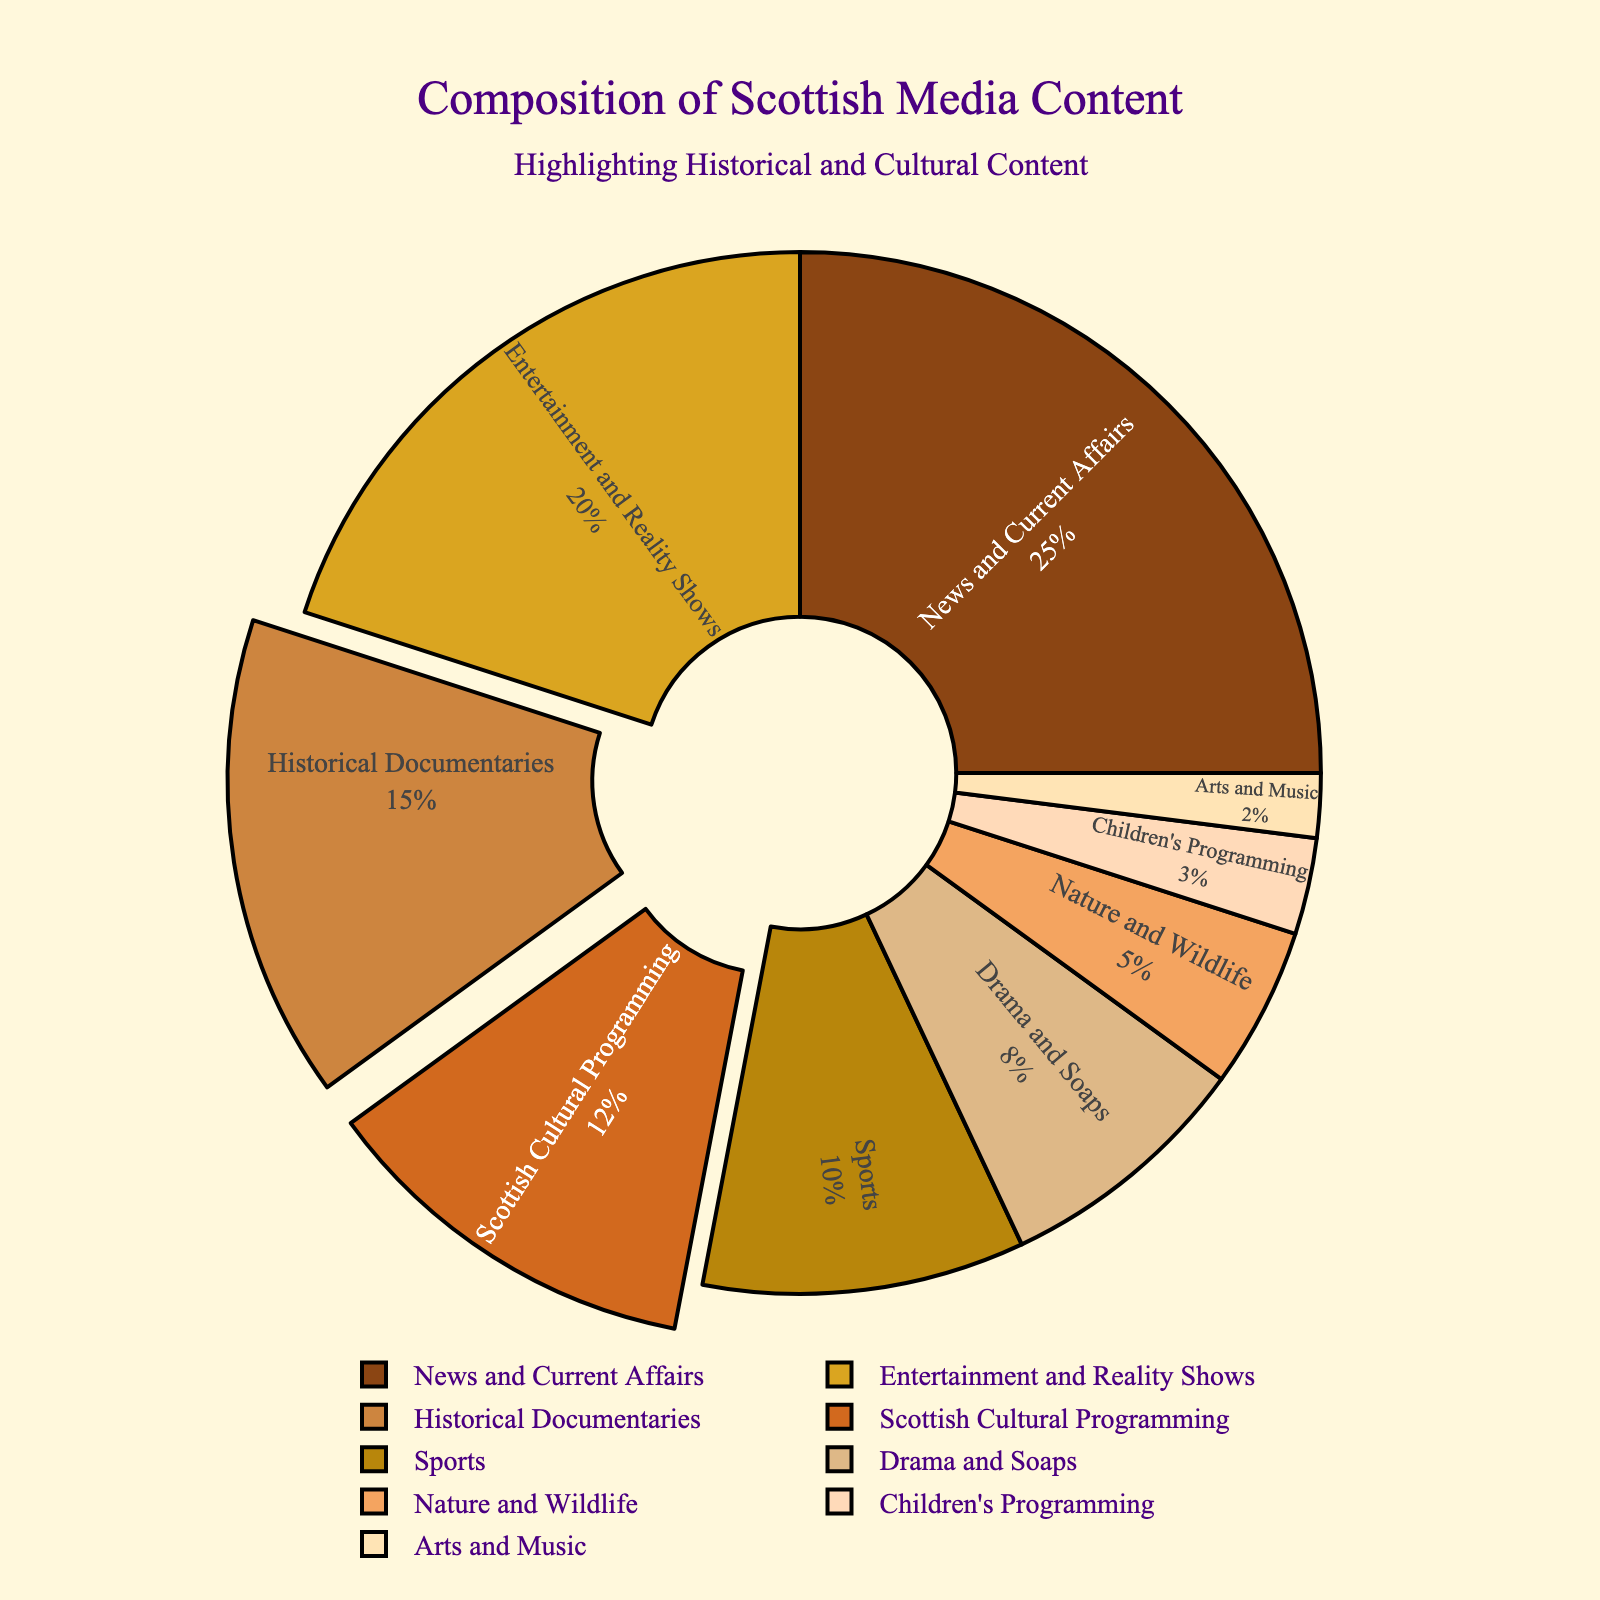What percentage of Scottish media content is dedicated to historical documentaries? The slice labeled "Historical Documentaries" shows the percentage directly on the pie chart.
Answer: 15% How does the percentage of Scottish cultural programming compare to the percentage of entertainment and reality shows? The slice labeled "Scottish Cultural Programming" is 12%, while "Entertainment and Reality Shows" is 20%.
Answer: It is less What is the total percentage of content dedicated to historical and cultural programming? Sum the percentages of "Historical Documentaries" (15%) and "Scottish Cultural Programming" (12%).
Answer: 27% Which genre has a higher percentage, sports or drama and soaps? Compare the percentages of "Sports" which is 10% and "Drama and Soaps" which is 8%.
Answer: Sports What is the combined percentage of children's programming, arts and music, and nature and wildlife? Sum the percentages of "Children's Programming" (3%), "Arts and Music" (2%), and "Nature and Wildlife" (5%).
Answer: 10% Which genre occupies the smallest section of the pie chart? The slice labeled "Arts and Music" shows the smallest percentage at 2%.
Answer: Arts and Music How much larger is the news and current affairs genre compared to the sports genre? Subtract the percentage of "Sports" (10%) from "News and Current Affairs" (25%).
Answer: 15% What proportion of the pie chart is represented by genres other than news and current affairs? Subtract the percentage of "News and Current Affairs" (25%) from 100%.
Answer: 75% Looking at the visual attributes, which genre's slice has a color similar to dark brown? The slice corresponding to "Historical Documentaries" has a dark brown color.
Answer: Historical Documentaries What is the second most prevalent genre in Scottish media content? The second largest slice after "News and Current Affairs" (25%) is "Entertainment and Reality Shows" (20%).
Answer: Entertainment and Reality Shows 